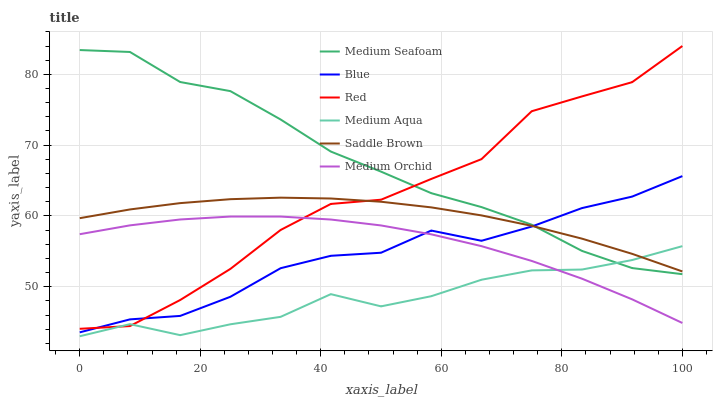Does Medium Aqua have the minimum area under the curve?
Answer yes or no. Yes. Does Medium Seafoam have the maximum area under the curve?
Answer yes or no. Yes. Does Medium Orchid have the minimum area under the curve?
Answer yes or no. No. Does Medium Orchid have the maximum area under the curve?
Answer yes or no. No. Is Saddle Brown the smoothest?
Answer yes or no. Yes. Is Red the roughest?
Answer yes or no. Yes. Is Medium Orchid the smoothest?
Answer yes or no. No. Is Medium Orchid the roughest?
Answer yes or no. No. Does Medium Aqua have the lowest value?
Answer yes or no. Yes. Does Medium Orchid have the lowest value?
Answer yes or no. No. Does Red have the highest value?
Answer yes or no. Yes. Does Medium Orchid have the highest value?
Answer yes or no. No. Is Medium Orchid less than Saddle Brown?
Answer yes or no. Yes. Is Saddle Brown greater than Medium Orchid?
Answer yes or no. Yes. Does Saddle Brown intersect Blue?
Answer yes or no. Yes. Is Saddle Brown less than Blue?
Answer yes or no. No. Is Saddle Brown greater than Blue?
Answer yes or no. No. Does Medium Orchid intersect Saddle Brown?
Answer yes or no. No. 